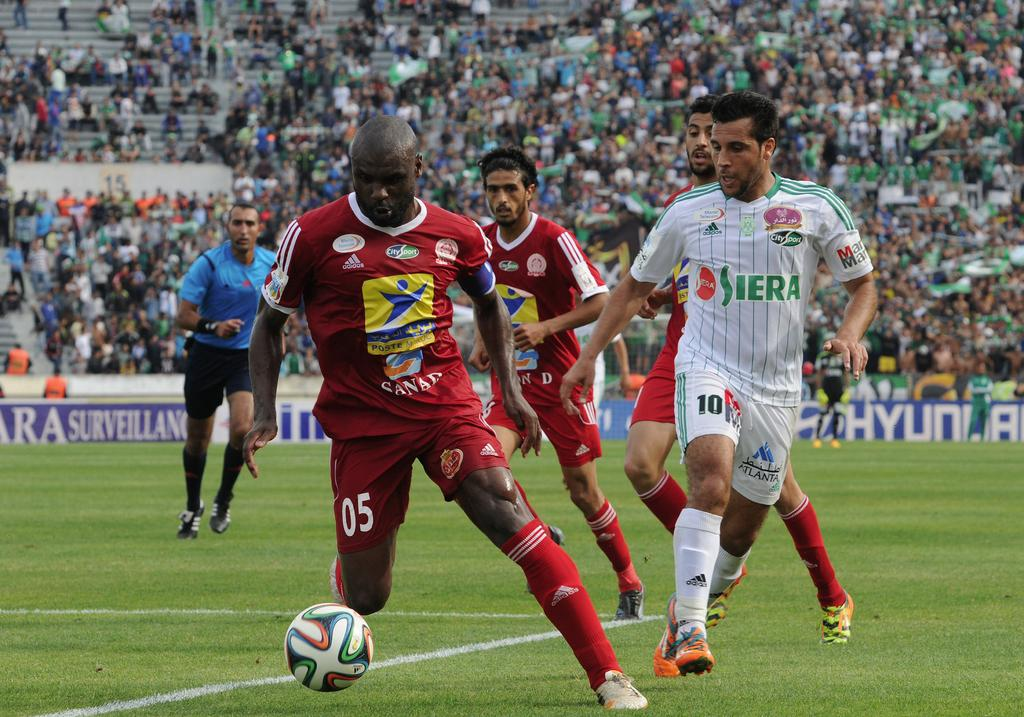<image>
Offer a succinct explanation of the picture presented. Soccer players on a field that is sponsored by Hyundai 